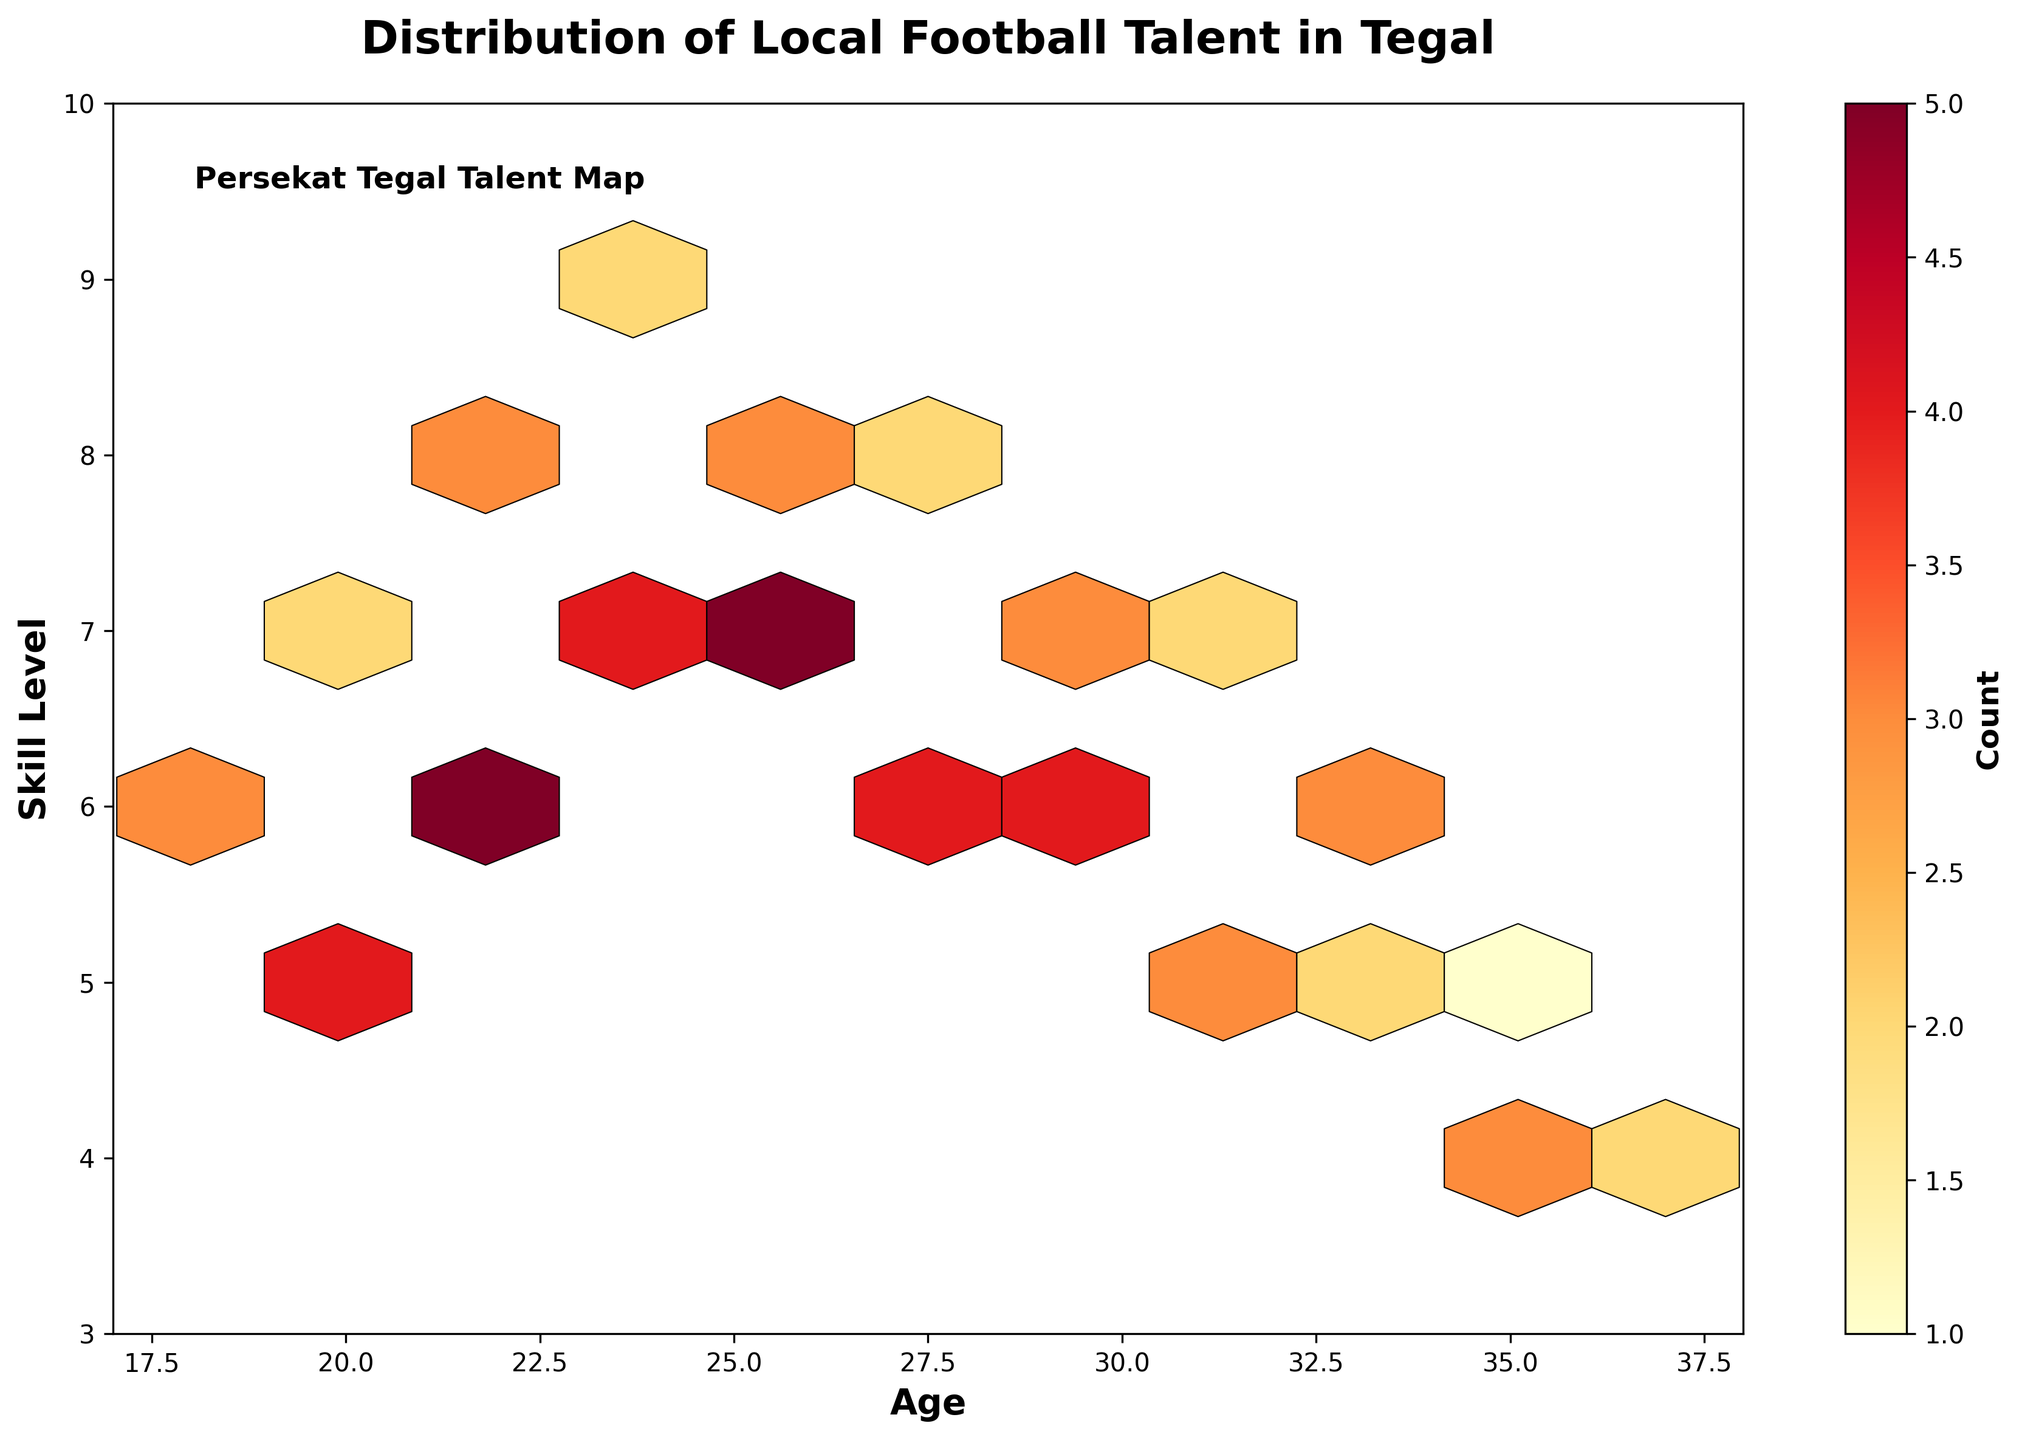What is the title of the figure? The title of the figure is usually written at the top and provides a summary of the plot's content.
Answer: Distribution of Local Football Talent in Tegal What is the age range displayed on the x-axis? The x-axis label shows the range of ages plotted, typically marked at the bottom axis of the figure.
Answer: 17 to 38 What does the color gradient in the hexagons represent? The color gradient in hexbin plots represents the value of a certain attribute, which can be deduced from the figure's color bar.
Answer: Count Which skill level has the highest count of players aged 24? Look for the data point at age 24 on the x-axis and check the corresponding hexagon's color intensity for the skill levels.
Answer: Skill Level 9 How many players are in the age group 21 with a skill level of 6? Find the hexagon for age 21 and skill level 6 and refer to the color bar to determine the count.
Answer: 5 What age group has the largest skill range among the players? Compare the skill ranges (distance on y-axis) for different age groups by examining the hexagon spread.
Answer: Age group 21 Which age group has the highest total number of players? Sum the counts for each age group and compare which sum is the highest.
Answer: Age group 21 Between players aged 30 and 33, which age has more representatives with a skill level of 7? Compare the hexagon counts for ages 30 and 33 with a skill level of 7.
Answer: Age 33 Which skill level shows a higher count, 5 or 8, for players aged 22? Compare the hexagon counts for skill levels 5 and 8 at age 22.
Answer: Skill Level 8 What does the label on the y-axis say? The y-axis label provides the name of what is measured on the y-axis.
Answer: Skill Level 